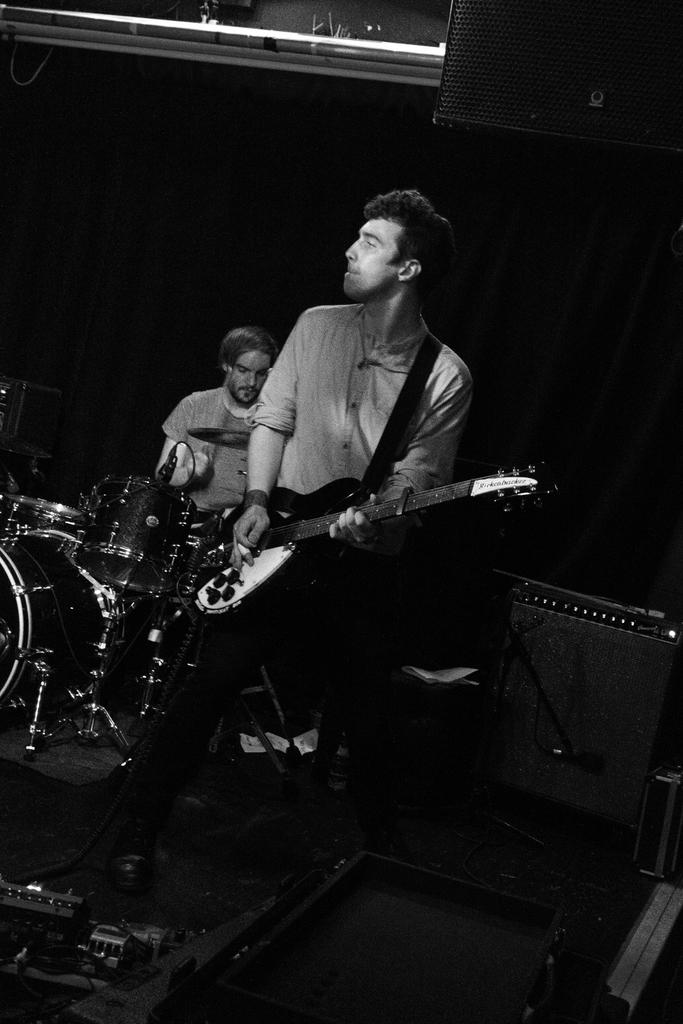What is the main activity being performed by the person in the image? The person in the image is playing a guitar. Can you describe the second person in the image? The second person in the image is playing drums. What type of musical instruments are being played in the image? The guitar and drums are being played in the image. What type of kite is the person flying in the image? There is no kite present in the image; the person is playing a guitar. Can you describe the facial expressions of the people in the image? The provided facts do not mention facial expressions, so we cannot describe them. 